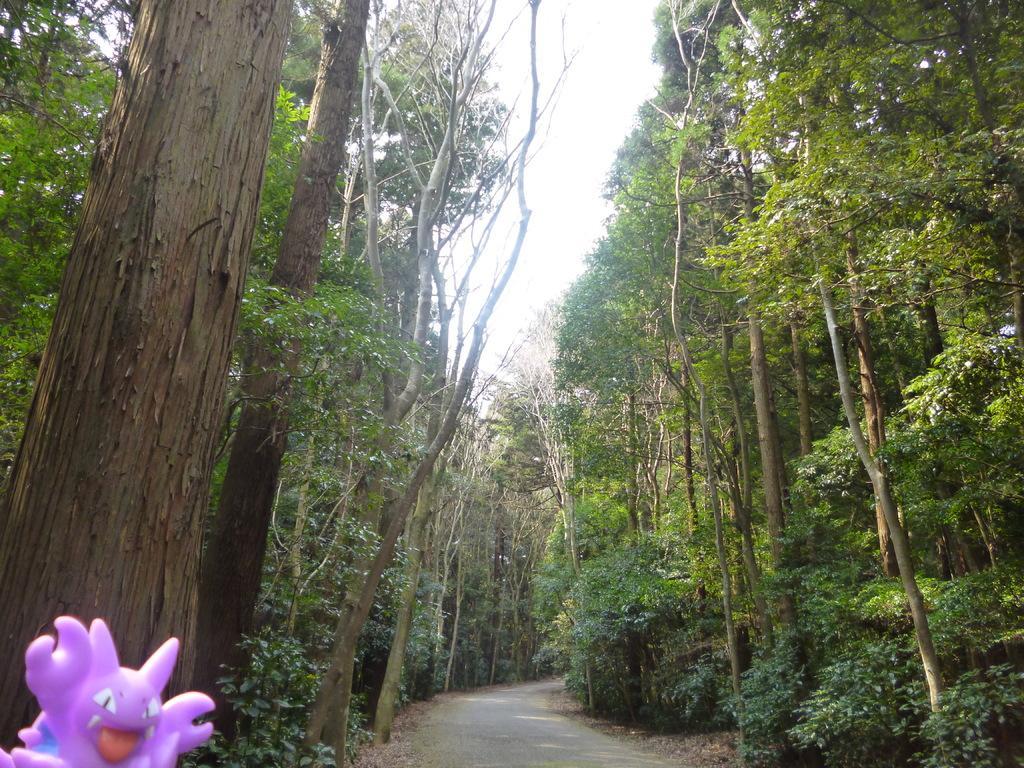Could you give a brief overview of what you see in this image? This is an outside view. At the bottom there is a road. On both sides of the road there are many trees. In the bottom left there is a toy. At the top of the image I can see the sky. 